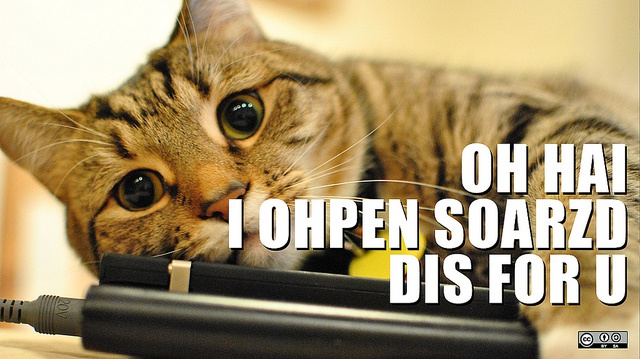Describe the objects in this image and their specific colors. I can see cat in ivory, white, olive, tan, and black tones, laptop in ivory, black, gray, and darkgray tones, and cell phone in ivory, black, white, tan, and gray tones in this image. 